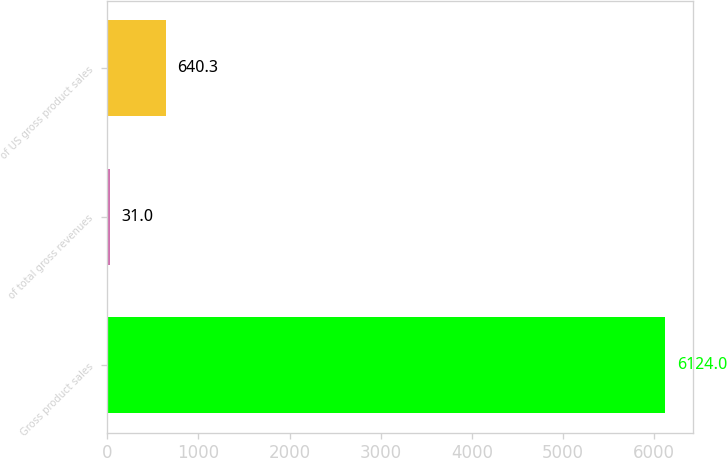Convert chart to OTSL. <chart><loc_0><loc_0><loc_500><loc_500><bar_chart><fcel>Gross product sales<fcel>of total gross revenues<fcel>of US gross product sales<nl><fcel>6124<fcel>31<fcel>640.3<nl></chart> 